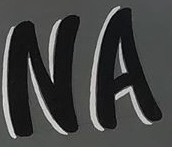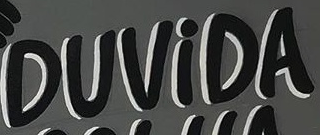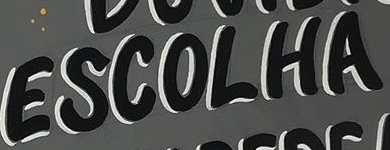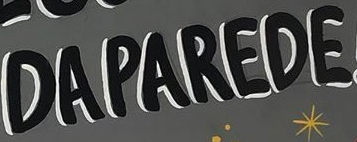Read the text content from these images in order, separated by a semicolon. NA; DUViDA; ESCOLHA; DAPAREDE 